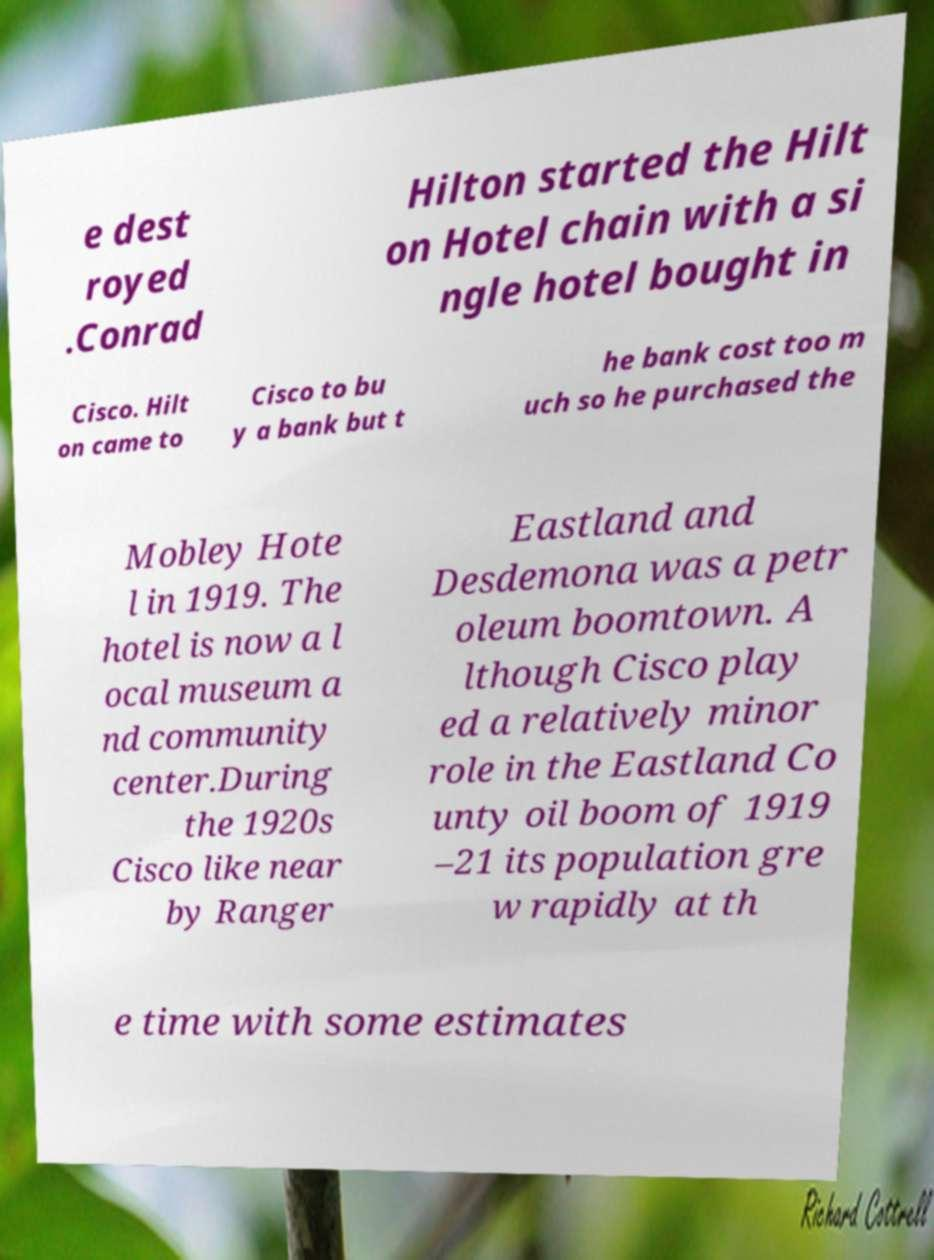Could you extract and type out the text from this image? e dest royed .Conrad Hilton started the Hilt on Hotel chain with a si ngle hotel bought in Cisco. Hilt on came to Cisco to bu y a bank but t he bank cost too m uch so he purchased the Mobley Hote l in 1919. The hotel is now a l ocal museum a nd community center.During the 1920s Cisco like near by Ranger Eastland and Desdemona was a petr oleum boomtown. A lthough Cisco play ed a relatively minor role in the Eastland Co unty oil boom of 1919 –21 its population gre w rapidly at th e time with some estimates 